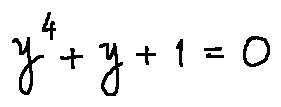Convert formula to latex. <formula><loc_0><loc_0><loc_500><loc_500>y ^ { 4 } + y + 1 = 0</formula> 